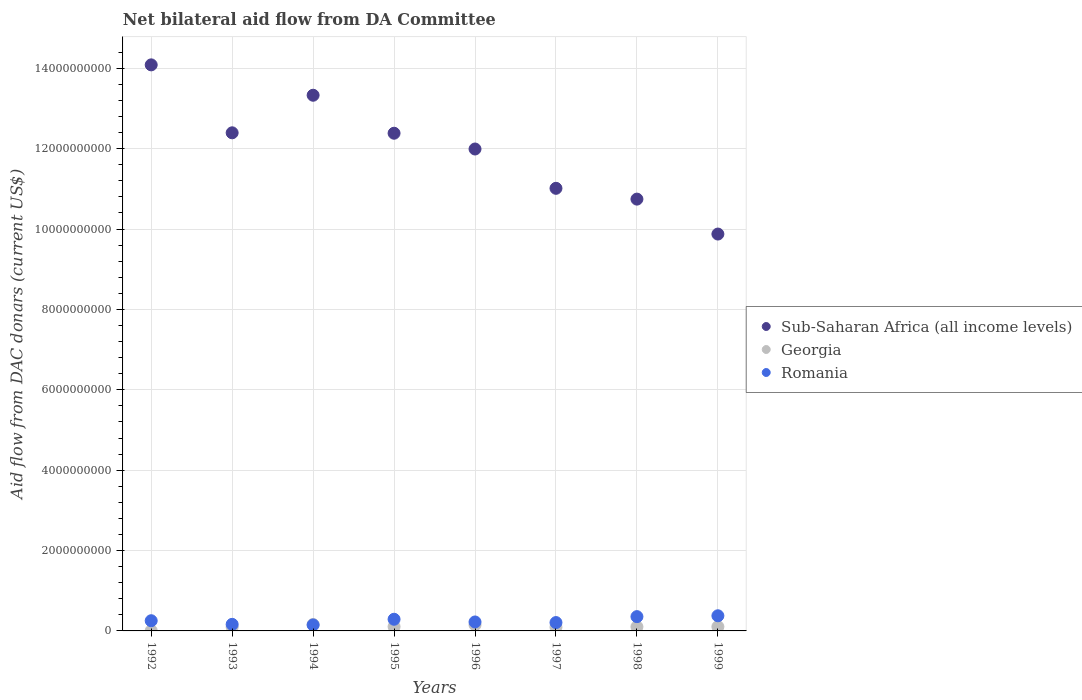How many different coloured dotlines are there?
Keep it short and to the point. 3. Is the number of dotlines equal to the number of legend labels?
Your answer should be very brief. Yes. What is the aid flow in in Sub-Saharan Africa (all income levels) in 1993?
Make the answer very short. 1.24e+1. Across all years, what is the maximum aid flow in in Sub-Saharan Africa (all income levels)?
Ensure brevity in your answer.  1.41e+1. Across all years, what is the minimum aid flow in in Sub-Saharan Africa (all income levels)?
Keep it short and to the point. 9.87e+09. What is the total aid flow in in Romania in the graph?
Offer a terse response. 2.02e+09. What is the difference between the aid flow in in Georgia in 1994 and that in 1996?
Your answer should be very brief. 1.08e+07. What is the difference between the aid flow in in Romania in 1993 and the aid flow in in Georgia in 1998?
Make the answer very short. 6.09e+07. What is the average aid flow in in Sub-Saharan Africa (all income levels) per year?
Keep it short and to the point. 1.20e+1. In the year 1992, what is the difference between the aid flow in in Sub-Saharan Africa (all income levels) and aid flow in in Romania?
Offer a very short reply. 1.38e+1. What is the ratio of the aid flow in in Romania in 1994 to that in 1998?
Your answer should be compact. 0.42. What is the difference between the highest and the second highest aid flow in in Georgia?
Provide a succinct answer. 1.08e+07. What is the difference between the highest and the lowest aid flow in in Romania?
Make the answer very short. 2.29e+08. In how many years, is the aid flow in in Romania greater than the average aid flow in in Romania taken over all years?
Offer a terse response. 4. How many years are there in the graph?
Your answer should be compact. 8. What is the difference between two consecutive major ticks on the Y-axis?
Offer a terse response. 2.00e+09. Does the graph contain any zero values?
Give a very brief answer. No. Does the graph contain grids?
Ensure brevity in your answer.  Yes. How many legend labels are there?
Keep it short and to the point. 3. How are the legend labels stacked?
Ensure brevity in your answer.  Vertical. What is the title of the graph?
Offer a very short reply. Net bilateral aid flow from DA Committee. Does "Bangladesh" appear as one of the legend labels in the graph?
Offer a terse response. No. What is the label or title of the X-axis?
Your answer should be very brief. Years. What is the label or title of the Y-axis?
Provide a succinct answer. Aid flow from DAC donars (current US$). What is the Aid flow from DAC donars (current US$) of Sub-Saharan Africa (all income levels) in 1992?
Offer a terse response. 1.41e+1. What is the Aid flow from DAC donars (current US$) in Georgia in 1992?
Your answer should be compact. 5.28e+06. What is the Aid flow from DAC donars (current US$) in Romania in 1992?
Ensure brevity in your answer.  2.54e+08. What is the Aid flow from DAC donars (current US$) of Sub-Saharan Africa (all income levels) in 1993?
Keep it short and to the point. 1.24e+1. What is the Aid flow from DAC donars (current US$) in Georgia in 1993?
Your answer should be compact. 9.56e+07. What is the Aid flow from DAC donars (current US$) of Romania in 1993?
Ensure brevity in your answer.  1.64e+08. What is the Aid flow from DAC donars (current US$) of Sub-Saharan Africa (all income levels) in 1994?
Your answer should be very brief. 1.33e+1. What is the Aid flow from DAC donars (current US$) in Georgia in 1994?
Offer a very short reply. 1.59e+08. What is the Aid flow from DAC donars (current US$) of Romania in 1994?
Make the answer very short. 1.48e+08. What is the Aid flow from DAC donars (current US$) of Sub-Saharan Africa (all income levels) in 1995?
Your answer should be compact. 1.24e+1. What is the Aid flow from DAC donars (current US$) in Georgia in 1995?
Offer a very short reply. 1.06e+08. What is the Aid flow from DAC donars (current US$) in Romania in 1995?
Your answer should be very brief. 2.90e+08. What is the Aid flow from DAC donars (current US$) in Sub-Saharan Africa (all income levels) in 1996?
Offer a very short reply. 1.20e+1. What is the Aid flow from DAC donars (current US$) in Georgia in 1996?
Your answer should be very brief. 1.48e+08. What is the Aid flow from DAC donars (current US$) in Romania in 1996?
Provide a succinct answer. 2.23e+08. What is the Aid flow from DAC donars (current US$) of Sub-Saharan Africa (all income levels) in 1997?
Offer a very short reply. 1.10e+1. What is the Aid flow from DAC donars (current US$) in Georgia in 1997?
Offer a terse response. 9.18e+07. What is the Aid flow from DAC donars (current US$) of Romania in 1997?
Provide a succinct answer. 2.08e+08. What is the Aid flow from DAC donars (current US$) in Sub-Saharan Africa (all income levels) in 1998?
Your answer should be compact. 1.07e+1. What is the Aid flow from DAC donars (current US$) of Georgia in 1998?
Offer a terse response. 1.03e+08. What is the Aid flow from DAC donars (current US$) in Romania in 1998?
Your answer should be compact. 3.55e+08. What is the Aid flow from DAC donars (current US$) in Sub-Saharan Africa (all income levels) in 1999?
Offer a terse response. 9.87e+09. What is the Aid flow from DAC donars (current US$) in Georgia in 1999?
Make the answer very short. 1.05e+08. What is the Aid flow from DAC donars (current US$) in Romania in 1999?
Provide a short and direct response. 3.77e+08. Across all years, what is the maximum Aid flow from DAC donars (current US$) of Sub-Saharan Africa (all income levels)?
Make the answer very short. 1.41e+1. Across all years, what is the maximum Aid flow from DAC donars (current US$) in Georgia?
Give a very brief answer. 1.59e+08. Across all years, what is the maximum Aid flow from DAC donars (current US$) of Romania?
Offer a very short reply. 3.77e+08. Across all years, what is the minimum Aid flow from DAC donars (current US$) of Sub-Saharan Africa (all income levels)?
Keep it short and to the point. 9.87e+09. Across all years, what is the minimum Aid flow from DAC donars (current US$) of Georgia?
Keep it short and to the point. 5.28e+06. Across all years, what is the minimum Aid flow from DAC donars (current US$) of Romania?
Make the answer very short. 1.48e+08. What is the total Aid flow from DAC donars (current US$) in Sub-Saharan Africa (all income levels) in the graph?
Provide a succinct answer. 9.58e+1. What is the total Aid flow from DAC donars (current US$) in Georgia in the graph?
Ensure brevity in your answer.  8.15e+08. What is the total Aid flow from DAC donars (current US$) in Romania in the graph?
Give a very brief answer. 2.02e+09. What is the difference between the Aid flow from DAC donars (current US$) of Sub-Saharan Africa (all income levels) in 1992 and that in 1993?
Your response must be concise. 1.69e+09. What is the difference between the Aid flow from DAC donars (current US$) in Georgia in 1992 and that in 1993?
Keep it short and to the point. -9.03e+07. What is the difference between the Aid flow from DAC donars (current US$) of Romania in 1992 and that in 1993?
Give a very brief answer. 9.02e+07. What is the difference between the Aid flow from DAC donars (current US$) in Sub-Saharan Africa (all income levels) in 1992 and that in 1994?
Your response must be concise. 7.56e+08. What is the difference between the Aid flow from DAC donars (current US$) in Georgia in 1992 and that in 1994?
Offer a very short reply. -1.54e+08. What is the difference between the Aid flow from DAC donars (current US$) of Romania in 1992 and that in 1994?
Ensure brevity in your answer.  1.05e+08. What is the difference between the Aid flow from DAC donars (current US$) of Sub-Saharan Africa (all income levels) in 1992 and that in 1995?
Your response must be concise. 1.70e+09. What is the difference between the Aid flow from DAC donars (current US$) of Georgia in 1992 and that in 1995?
Your answer should be very brief. -1.01e+08. What is the difference between the Aid flow from DAC donars (current US$) of Romania in 1992 and that in 1995?
Your answer should be compact. -3.64e+07. What is the difference between the Aid flow from DAC donars (current US$) in Sub-Saharan Africa (all income levels) in 1992 and that in 1996?
Your answer should be compact. 2.09e+09. What is the difference between the Aid flow from DAC donars (current US$) in Georgia in 1992 and that in 1996?
Keep it short and to the point. -1.43e+08. What is the difference between the Aid flow from DAC donars (current US$) of Romania in 1992 and that in 1996?
Keep it short and to the point. 3.07e+07. What is the difference between the Aid flow from DAC donars (current US$) in Sub-Saharan Africa (all income levels) in 1992 and that in 1997?
Your answer should be compact. 3.07e+09. What is the difference between the Aid flow from DAC donars (current US$) of Georgia in 1992 and that in 1997?
Ensure brevity in your answer.  -8.65e+07. What is the difference between the Aid flow from DAC donars (current US$) in Romania in 1992 and that in 1997?
Provide a succinct answer. 4.58e+07. What is the difference between the Aid flow from DAC donars (current US$) of Sub-Saharan Africa (all income levels) in 1992 and that in 1998?
Give a very brief answer. 3.34e+09. What is the difference between the Aid flow from DAC donars (current US$) in Georgia in 1992 and that in 1998?
Offer a very short reply. -9.74e+07. What is the difference between the Aid flow from DAC donars (current US$) in Romania in 1992 and that in 1998?
Keep it short and to the point. -1.02e+08. What is the difference between the Aid flow from DAC donars (current US$) of Sub-Saharan Africa (all income levels) in 1992 and that in 1999?
Keep it short and to the point. 4.21e+09. What is the difference between the Aid flow from DAC donars (current US$) in Georgia in 1992 and that in 1999?
Your answer should be very brief. -1.00e+08. What is the difference between the Aid flow from DAC donars (current US$) in Romania in 1992 and that in 1999?
Your answer should be very brief. -1.23e+08. What is the difference between the Aid flow from DAC donars (current US$) of Sub-Saharan Africa (all income levels) in 1993 and that in 1994?
Keep it short and to the point. -9.35e+08. What is the difference between the Aid flow from DAC donars (current US$) of Georgia in 1993 and that in 1994?
Ensure brevity in your answer.  -6.37e+07. What is the difference between the Aid flow from DAC donars (current US$) of Romania in 1993 and that in 1994?
Ensure brevity in your answer.  1.53e+07. What is the difference between the Aid flow from DAC donars (current US$) of Sub-Saharan Africa (all income levels) in 1993 and that in 1995?
Your answer should be compact. 1.05e+07. What is the difference between the Aid flow from DAC donars (current US$) in Georgia in 1993 and that in 1995?
Give a very brief answer. -1.09e+07. What is the difference between the Aid flow from DAC donars (current US$) of Romania in 1993 and that in 1995?
Make the answer very short. -1.27e+08. What is the difference between the Aid flow from DAC donars (current US$) of Sub-Saharan Africa (all income levels) in 1993 and that in 1996?
Your answer should be compact. 4.03e+08. What is the difference between the Aid flow from DAC donars (current US$) in Georgia in 1993 and that in 1996?
Your answer should be very brief. -5.29e+07. What is the difference between the Aid flow from DAC donars (current US$) in Romania in 1993 and that in 1996?
Offer a very short reply. -5.95e+07. What is the difference between the Aid flow from DAC donars (current US$) of Sub-Saharan Africa (all income levels) in 1993 and that in 1997?
Your answer should be very brief. 1.38e+09. What is the difference between the Aid flow from DAC donars (current US$) of Georgia in 1993 and that in 1997?
Give a very brief answer. 3.80e+06. What is the difference between the Aid flow from DAC donars (current US$) of Romania in 1993 and that in 1997?
Provide a succinct answer. -4.44e+07. What is the difference between the Aid flow from DAC donars (current US$) in Sub-Saharan Africa (all income levels) in 1993 and that in 1998?
Give a very brief answer. 1.65e+09. What is the difference between the Aid flow from DAC donars (current US$) in Georgia in 1993 and that in 1998?
Your answer should be compact. -7.10e+06. What is the difference between the Aid flow from DAC donars (current US$) in Romania in 1993 and that in 1998?
Give a very brief answer. -1.92e+08. What is the difference between the Aid flow from DAC donars (current US$) in Sub-Saharan Africa (all income levels) in 1993 and that in 1999?
Keep it short and to the point. 2.52e+09. What is the difference between the Aid flow from DAC donars (current US$) of Georgia in 1993 and that in 1999?
Provide a succinct answer. -9.75e+06. What is the difference between the Aid flow from DAC donars (current US$) of Romania in 1993 and that in 1999?
Ensure brevity in your answer.  -2.13e+08. What is the difference between the Aid flow from DAC donars (current US$) of Sub-Saharan Africa (all income levels) in 1994 and that in 1995?
Ensure brevity in your answer.  9.45e+08. What is the difference between the Aid flow from DAC donars (current US$) of Georgia in 1994 and that in 1995?
Provide a short and direct response. 5.28e+07. What is the difference between the Aid flow from DAC donars (current US$) in Romania in 1994 and that in 1995?
Provide a succinct answer. -1.42e+08. What is the difference between the Aid flow from DAC donars (current US$) of Sub-Saharan Africa (all income levels) in 1994 and that in 1996?
Your response must be concise. 1.34e+09. What is the difference between the Aid flow from DAC donars (current US$) in Georgia in 1994 and that in 1996?
Keep it short and to the point. 1.08e+07. What is the difference between the Aid flow from DAC donars (current US$) of Romania in 1994 and that in 1996?
Make the answer very short. -7.47e+07. What is the difference between the Aid flow from DAC donars (current US$) in Sub-Saharan Africa (all income levels) in 1994 and that in 1997?
Offer a terse response. 2.32e+09. What is the difference between the Aid flow from DAC donars (current US$) of Georgia in 1994 and that in 1997?
Provide a succinct answer. 6.75e+07. What is the difference between the Aid flow from DAC donars (current US$) in Romania in 1994 and that in 1997?
Your response must be concise. -5.97e+07. What is the difference between the Aid flow from DAC donars (current US$) of Sub-Saharan Africa (all income levels) in 1994 and that in 1998?
Your answer should be very brief. 2.58e+09. What is the difference between the Aid flow from DAC donars (current US$) in Georgia in 1994 and that in 1998?
Offer a very short reply. 5.66e+07. What is the difference between the Aid flow from DAC donars (current US$) of Romania in 1994 and that in 1998?
Provide a succinct answer. -2.07e+08. What is the difference between the Aid flow from DAC donars (current US$) of Sub-Saharan Africa (all income levels) in 1994 and that in 1999?
Your answer should be very brief. 3.45e+09. What is the difference between the Aid flow from DAC donars (current US$) of Georgia in 1994 and that in 1999?
Provide a short and direct response. 5.40e+07. What is the difference between the Aid flow from DAC donars (current US$) of Romania in 1994 and that in 1999?
Give a very brief answer. -2.29e+08. What is the difference between the Aid flow from DAC donars (current US$) of Sub-Saharan Africa (all income levels) in 1995 and that in 1996?
Your answer should be compact. 3.93e+08. What is the difference between the Aid flow from DAC donars (current US$) in Georgia in 1995 and that in 1996?
Offer a terse response. -4.20e+07. What is the difference between the Aid flow from DAC donars (current US$) of Romania in 1995 and that in 1996?
Offer a terse response. 6.71e+07. What is the difference between the Aid flow from DAC donars (current US$) of Sub-Saharan Africa (all income levels) in 1995 and that in 1997?
Provide a succinct answer. 1.37e+09. What is the difference between the Aid flow from DAC donars (current US$) of Georgia in 1995 and that in 1997?
Your answer should be compact. 1.47e+07. What is the difference between the Aid flow from DAC donars (current US$) of Romania in 1995 and that in 1997?
Your answer should be very brief. 8.22e+07. What is the difference between the Aid flow from DAC donars (current US$) in Sub-Saharan Africa (all income levels) in 1995 and that in 1998?
Offer a very short reply. 1.64e+09. What is the difference between the Aid flow from DAC donars (current US$) in Georgia in 1995 and that in 1998?
Give a very brief answer. 3.78e+06. What is the difference between the Aid flow from DAC donars (current US$) in Romania in 1995 and that in 1998?
Offer a very short reply. -6.53e+07. What is the difference between the Aid flow from DAC donars (current US$) of Sub-Saharan Africa (all income levels) in 1995 and that in 1999?
Offer a terse response. 2.51e+09. What is the difference between the Aid flow from DAC donars (current US$) in Georgia in 1995 and that in 1999?
Offer a terse response. 1.13e+06. What is the difference between the Aid flow from DAC donars (current US$) of Romania in 1995 and that in 1999?
Keep it short and to the point. -8.68e+07. What is the difference between the Aid flow from DAC donars (current US$) of Sub-Saharan Africa (all income levels) in 1996 and that in 1997?
Keep it short and to the point. 9.78e+08. What is the difference between the Aid flow from DAC donars (current US$) of Georgia in 1996 and that in 1997?
Offer a very short reply. 5.67e+07. What is the difference between the Aid flow from DAC donars (current US$) in Romania in 1996 and that in 1997?
Offer a very short reply. 1.51e+07. What is the difference between the Aid flow from DAC donars (current US$) of Sub-Saharan Africa (all income levels) in 1996 and that in 1998?
Make the answer very short. 1.25e+09. What is the difference between the Aid flow from DAC donars (current US$) of Georgia in 1996 and that in 1998?
Provide a succinct answer. 4.58e+07. What is the difference between the Aid flow from DAC donars (current US$) of Romania in 1996 and that in 1998?
Ensure brevity in your answer.  -1.32e+08. What is the difference between the Aid flow from DAC donars (current US$) in Sub-Saharan Africa (all income levels) in 1996 and that in 1999?
Provide a short and direct response. 2.12e+09. What is the difference between the Aid flow from DAC donars (current US$) of Georgia in 1996 and that in 1999?
Your response must be concise. 4.32e+07. What is the difference between the Aid flow from DAC donars (current US$) of Romania in 1996 and that in 1999?
Your response must be concise. -1.54e+08. What is the difference between the Aid flow from DAC donars (current US$) of Sub-Saharan Africa (all income levels) in 1997 and that in 1998?
Ensure brevity in your answer.  2.69e+08. What is the difference between the Aid flow from DAC donars (current US$) in Georgia in 1997 and that in 1998?
Ensure brevity in your answer.  -1.09e+07. What is the difference between the Aid flow from DAC donars (current US$) in Romania in 1997 and that in 1998?
Provide a succinct answer. -1.47e+08. What is the difference between the Aid flow from DAC donars (current US$) in Sub-Saharan Africa (all income levels) in 1997 and that in 1999?
Provide a succinct answer. 1.14e+09. What is the difference between the Aid flow from DAC donars (current US$) in Georgia in 1997 and that in 1999?
Make the answer very short. -1.36e+07. What is the difference between the Aid flow from DAC donars (current US$) in Romania in 1997 and that in 1999?
Offer a terse response. -1.69e+08. What is the difference between the Aid flow from DAC donars (current US$) of Sub-Saharan Africa (all income levels) in 1998 and that in 1999?
Offer a very short reply. 8.69e+08. What is the difference between the Aid flow from DAC donars (current US$) in Georgia in 1998 and that in 1999?
Your response must be concise. -2.65e+06. What is the difference between the Aid flow from DAC donars (current US$) of Romania in 1998 and that in 1999?
Your response must be concise. -2.15e+07. What is the difference between the Aid flow from DAC donars (current US$) in Sub-Saharan Africa (all income levels) in 1992 and the Aid flow from DAC donars (current US$) in Georgia in 1993?
Make the answer very short. 1.40e+1. What is the difference between the Aid flow from DAC donars (current US$) of Sub-Saharan Africa (all income levels) in 1992 and the Aid flow from DAC donars (current US$) of Romania in 1993?
Provide a succinct answer. 1.39e+1. What is the difference between the Aid flow from DAC donars (current US$) in Georgia in 1992 and the Aid flow from DAC donars (current US$) in Romania in 1993?
Ensure brevity in your answer.  -1.58e+08. What is the difference between the Aid flow from DAC donars (current US$) of Sub-Saharan Africa (all income levels) in 1992 and the Aid flow from DAC donars (current US$) of Georgia in 1994?
Provide a short and direct response. 1.39e+1. What is the difference between the Aid flow from DAC donars (current US$) of Sub-Saharan Africa (all income levels) in 1992 and the Aid flow from DAC donars (current US$) of Romania in 1994?
Your response must be concise. 1.39e+1. What is the difference between the Aid flow from DAC donars (current US$) in Georgia in 1992 and the Aid flow from DAC donars (current US$) in Romania in 1994?
Ensure brevity in your answer.  -1.43e+08. What is the difference between the Aid flow from DAC donars (current US$) in Sub-Saharan Africa (all income levels) in 1992 and the Aid flow from DAC donars (current US$) in Georgia in 1995?
Your answer should be compact. 1.40e+1. What is the difference between the Aid flow from DAC donars (current US$) of Sub-Saharan Africa (all income levels) in 1992 and the Aid flow from DAC donars (current US$) of Romania in 1995?
Your answer should be compact. 1.38e+1. What is the difference between the Aid flow from DAC donars (current US$) of Georgia in 1992 and the Aid flow from DAC donars (current US$) of Romania in 1995?
Keep it short and to the point. -2.85e+08. What is the difference between the Aid flow from DAC donars (current US$) in Sub-Saharan Africa (all income levels) in 1992 and the Aid flow from DAC donars (current US$) in Georgia in 1996?
Provide a short and direct response. 1.39e+1. What is the difference between the Aid flow from DAC donars (current US$) of Sub-Saharan Africa (all income levels) in 1992 and the Aid flow from DAC donars (current US$) of Romania in 1996?
Provide a short and direct response. 1.39e+1. What is the difference between the Aid flow from DAC donars (current US$) in Georgia in 1992 and the Aid flow from DAC donars (current US$) in Romania in 1996?
Provide a short and direct response. -2.18e+08. What is the difference between the Aid flow from DAC donars (current US$) in Sub-Saharan Africa (all income levels) in 1992 and the Aid flow from DAC donars (current US$) in Georgia in 1997?
Your answer should be very brief. 1.40e+1. What is the difference between the Aid flow from DAC donars (current US$) in Sub-Saharan Africa (all income levels) in 1992 and the Aid flow from DAC donars (current US$) in Romania in 1997?
Offer a terse response. 1.39e+1. What is the difference between the Aid flow from DAC donars (current US$) of Georgia in 1992 and the Aid flow from DAC donars (current US$) of Romania in 1997?
Provide a short and direct response. -2.03e+08. What is the difference between the Aid flow from DAC donars (current US$) in Sub-Saharan Africa (all income levels) in 1992 and the Aid flow from DAC donars (current US$) in Georgia in 1998?
Ensure brevity in your answer.  1.40e+1. What is the difference between the Aid flow from DAC donars (current US$) of Sub-Saharan Africa (all income levels) in 1992 and the Aid flow from DAC donars (current US$) of Romania in 1998?
Keep it short and to the point. 1.37e+1. What is the difference between the Aid flow from DAC donars (current US$) in Georgia in 1992 and the Aid flow from DAC donars (current US$) in Romania in 1998?
Your response must be concise. -3.50e+08. What is the difference between the Aid flow from DAC donars (current US$) of Sub-Saharan Africa (all income levels) in 1992 and the Aid flow from DAC donars (current US$) of Georgia in 1999?
Offer a terse response. 1.40e+1. What is the difference between the Aid flow from DAC donars (current US$) in Sub-Saharan Africa (all income levels) in 1992 and the Aid flow from DAC donars (current US$) in Romania in 1999?
Ensure brevity in your answer.  1.37e+1. What is the difference between the Aid flow from DAC donars (current US$) in Georgia in 1992 and the Aid flow from DAC donars (current US$) in Romania in 1999?
Offer a terse response. -3.72e+08. What is the difference between the Aid flow from DAC donars (current US$) in Sub-Saharan Africa (all income levels) in 1993 and the Aid flow from DAC donars (current US$) in Georgia in 1994?
Ensure brevity in your answer.  1.22e+1. What is the difference between the Aid flow from DAC donars (current US$) of Sub-Saharan Africa (all income levels) in 1993 and the Aid flow from DAC donars (current US$) of Romania in 1994?
Your answer should be compact. 1.22e+1. What is the difference between the Aid flow from DAC donars (current US$) in Georgia in 1993 and the Aid flow from DAC donars (current US$) in Romania in 1994?
Offer a terse response. -5.28e+07. What is the difference between the Aid flow from DAC donars (current US$) of Sub-Saharan Africa (all income levels) in 1993 and the Aid flow from DAC donars (current US$) of Georgia in 1995?
Provide a short and direct response. 1.23e+1. What is the difference between the Aid flow from DAC donars (current US$) of Sub-Saharan Africa (all income levels) in 1993 and the Aid flow from DAC donars (current US$) of Romania in 1995?
Provide a succinct answer. 1.21e+1. What is the difference between the Aid flow from DAC donars (current US$) of Georgia in 1993 and the Aid flow from DAC donars (current US$) of Romania in 1995?
Ensure brevity in your answer.  -1.95e+08. What is the difference between the Aid flow from DAC donars (current US$) of Sub-Saharan Africa (all income levels) in 1993 and the Aid flow from DAC donars (current US$) of Georgia in 1996?
Keep it short and to the point. 1.22e+1. What is the difference between the Aid flow from DAC donars (current US$) of Sub-Saharan Africa (all income levels) in 1993 and the Aid flow from DAC donars (current US$) of Romania in 1996?
Offer a terse response. 1.22e+1. What is the difference between the Aid flow from DAC donars (current US$) of Georgia in 1993 and the Aid flow from DAC donars (current US$) of Romania in 1996?
Provide a succinct answer. -1.27e+08. What is the difference between the Aid flow from DAC donars (current US$) in Sub-Saharan Africa (all income levels) in 1993 and the Aid flow from DAC donars (current US$) in Georgia in 1997?
Give a very brief answer. 1.23e+1. What is the difference between the Aid flow from DAC donars (current US$) in Sub-Saharan Africa (all income levels) in 1993 and the Aid flow from DAC donars (current US$) in Romania in 1997?
Your answer should be compact. 1.22e+1. What is the difference between the Aid flow from DAC donars (current US$) of Georgia in 1993 and the Aid flow from DAC donars (current US$) of Romania in 1997?
Provide a short and direct response. -1.12e+08. What is the difference between the Aid flow from DAC donars (current US$) in Sub-Saharan Africa (all income levels) in 1993 and the Aid flow from DAC donars (current US$) in Georgia in 1998?
Your response must be concise. 1.23e+1. What is the difference between the Aid flow from DAC donars (current US$) of Sub-Saharan Africa (all income levels) in 1993 and the Aid flow from DAC donars (current US$) of Romania in 1998?
Offer a very short reply. 1.20e+1. What is the difference between the Aid flow from DAC donars (current US$) of Georgia in 1993 and the Aid flow from DAC donars (current US$) of Romania in 1998?
Offer a terse response. -2.60e+08. What is the difference between the Aid flow from DAC donars (current US$) of Sub-Saharan Africa (all income levels) in 1993 and the Aid flow from DAC donars (current US$) of Georgia in 1999?
Give a very brief answer. 1.23e+1. What is the difference between the Aid flow from DAC donars (current US$) in Sub-Saharan Africa (all income levels) in 1993 and the Aid flow from DAC donars (current US$) in Romania in 1999?
Give a very brief answer. 1.20e+1. What is the difference between the Aid flow from DAC donars (current US$) of Georgia in 1993 and the Aid flow from DAC donars (current US$) of Romania in 1999?
Your answer should be very brief. -2.81e+08. What is the difference between the Aid flow from DAC donars (current US$) in Sub-Saharan Africa (all income levels) in 1994 and the Aid flow from DAC donars (current US$) in Georgia in 1995?
Give a very brief answer. 1.32e+1. What is the difference between the Aid flow from DAC donars (current US$) of Sub-Saharan Africa (all income levels) in 1994 and the Aid flow from DAC donars (current US$) of Romania in 1995?
Ensure brevity in your answer.  1.30e+1. What is the difference between the Aid flow from DAC donars (current US$) in Georgia in 1994 and the Aid flow from DAC donars (current US$) in Romania in 1995?
Provide a succinct answer. -1.31e+08. What is the difference between the Aid flow from DAC donars (current US$) in Sub-Saharan Africa (all income levels) in 1994 and the Aid flow from DAC donars (current US$) in Georgia in 1996?
Give a very brief answer. 1.32e+1. What is the difference between the Aid flow from DAC donars (current US$) of Sub-Saharan Africa (all income levels) in 1994 and the Aid flow from DAC donars (current US$) of Romania in 1996?
Your answer should be very brief. 1.31e+1. What is the difference between the Aid flow from DAC donars (current US$) in Georgia in 1994 and the Aid flow from DAC donars (current US$) in Romania in 1996?
Your answer should be compact. -6.38e+07. What is the difference between the Aid flow from DAC donars (current US$) of Sub-Saharan Africa (all income levels) in 1994 and the Aid flow from DAC donars (current US$) of Georgia in 1997?
Offer a very short reply. 1.32e+1. What is the difference between the Aid flow from DAC donars (current US$) in Sub-Saharan Africa (all income levels) in 1994 and the Aid flow from DAC donars (current US$) in Romania in 1997?
Make the answer very short. 1.31e+1. What is the difference between the Aid flow from DAC donars (current US$) in Georgia in 1994 and the Aid flow from DAC donars (current US$) in Romania in 1997?
Offer a terse response. -4.87e+07. What is the difference between the Aid flow from DAC donars (current US$) in Sub-Saharan Africa (all income levels) in 1994 and the Aid flow from DAC donars (current US$) in Georgia in 1998?
Provide a succinct answer. 1.32e+1. What is the difference between the Aid flow from DAC donars (current US$) in Sub-Saharan Africa (all income levels) in 1994 and the Aid flow from DAC donars (current US$) in Romania in 1998?
Ensure brevity in your answer.  1.30e+1. What is the difference between the Aid flow from DAC donars (current US$) of Georgia in 1994 and the Aid flow from DAC donars (current US$) of Romania in 1998?
Provide a short and direct response. -1.96e+08. What is the difference between the Aid flow from DAC donars (current US$) of Sub-Saharan Africa (all income levels) in 1994 and the Aid flow from DAC donars (current US$) of Georgia in 1999?
Provide a succinct answer. 1.32e+1. What is the difference between the Aid flow from DAC donars (current US$) of Sub-Saharan Africa (all income levels) in 1994 and the Aid flow from DAC donars (current US$) of Romania in 1999?
Your response must be concise. 1.30e+1. What is the difference between the Aid flow from DAC donars (current US$) of Georgia in 1994 and the Aid flow from DAC donars (current US$) of Romania in 1999?
Make the answer very short. -2.18e+08. What is the difference between the Aid flow from DAC donars (current US$) in Sub-Saharan Africa (all income levels) in 1995 and the Aid flow from DAC donars (current US$) in Georgia in 1996?
Provide a succinct answer. 1.22e+1. What is the difference between the Aid flow from DAC donars (current US$) of Sub-Saharan Africa (all income levels) in 1995 and the Aid flow from DAC donars (current US$) of Romania in 1996?
Make the answer very short. 1.22e+1. What is the difference between the Aid flow from DAC donars (current US$) of Georgia in 1995 and the Aid flow from DAC donars (current US$) of Romania in 1996?
Ensure brevity in your answer.  -1.17e+08. What is the difference between the Aid flow from DAC donars (current US$) in Sub-Saharan Africa (all income levels) in 1995 and the Aid flow from DAC donars (current US$) in Georgia in 1997?
Offer a terse response. 1.23e+1. What is the difference between the Aid flow from DAC donars (current US$) of Sub-Saharan Africa (all income levels) in 1995 and the Aid flow from DAC donars (current US$) of Romania in 1997?
Provide a short and direct response. 1.22e+1. What is the difference between the Aid flow from DAC donars (current US$) of Georgia in 1995 and the Aid flow from DAC donars (current US$) of Romania in 1997?
Make the answer very short. -1.02e+08. What is the difference between the Aid flow from DAC donars (current US$) of Sub-Saharan Africa (all income levels) in 1995 and the Aid flow from DAC donars (current US$) of Georgia in 1998?
Your answer should be very brief. 1.23e+1. What is the difference between the Aid flow from DAC donars (current US$) in Sub-Saharan Africa (all income levels) in 1995 and the Aid flow from DAC donars (current US$) in Romania in 1998?
Give a very brief answer. 1.20e+1. What is the difference between the Aid flow from DAC donars (current US$) in Georgia in 1995 and the Aid flow from DAC donars (current US$) in Romania in 1998?
Ensure brevity in your answer.  -2.49e+08. What is the difference between the Aid flow from DAC donars (current US$) in Sub-Saharan Africa (all income levels) in 1995 and the Aid flow from DAC donars (current US$) in Georgia in 1999?
Offer a terse response. 1.23e+1. What is the difference between the Aid flow from DAC donars (current US$) of Sub-Saharan Africa (all income levels) in 1995 and the Aid flow from DAC donars (current US$) of Romania in 1999?
Keep it short and to the point. 1.20e+1. What is the difference between the Aid flow from DAC donars (current US$) of Georgia in 1995 and the Aid flow from DAC donars (current US$) of Romania in 1999?
Offer a terse response. -2.70e+08. What is the difference between the Aid flow from DAC donars (current US$) of Sub-Saharan Africa (all income levels) in 1996 and the Aid flow from DAC donars (current US$) of Georgia in 1997?
Offer a terse response. 1.19e+1. What is the difference between the Aid flow from DAC donars (current US$) in Sub-Saharan Africa (all income levels) in 1996 and the Aid flow from DAC donars (current US$) in Romania in 1997?
Your answer should be very brief. 1.18e+1. What is the difference between the Aid flow from DAC donars (current US$) in Georgia in 1996 and the Aid flow from DAC donars (current US$) in Romania in 1997?
Offer a very short reply. -5.95e+07. What is the difference between the Aid flow from DAC donars (current US$) of Sub-Saharan Africa (all income levels) in 1996 and the Aid flow from DAC donars (current US$) of Georgia in 1998?
Provide a short and direct response. 1.19e+1. What is the difference between the Aid flow from DAC donars (current US$) in Sub-Saharan Africa (all income levels) in 1996 and the Aid flow from DAC donars (current US$) in Romania in 1998?
Keep it short and to the point. 1.16e+1. What is the difference between the Aid flow from DAC donars (current US$) in Georgia in 1996 and the Aid flow from DAC donars (current US$) in Romania in 1998?
Offer a terse response. -2.07e+08. What is the difference between the Aid flow from DAC donars (current US$) in Sub-Saharan Africa (all income levels) in 1996 and the Aid flow from DAC donars (current US$) in Georgia in 1999?
Your answer should be compact. 1.19e+1. What is the difference between the Aid flow from DAC donars (current US$) of Sub-Saharan Africa (all income levels) in 1996 and the Aid flow from DAC donars (current US$) of Romania in 1999?
Offer a terse response. 1.16e+1. What is the difference between the Aid flow from DAC donars (current US$) in Georgia in 1996 and the Aid flow from DAC donars (current US$) in Romania in 1999?
Your answer should be very brief. -2.28e+08. What is the difference between the Aid flow from DAC donars (current US$) in Sub-Saharan Africa (all income levels) in 1997 and the Aid flow from DAC donars (current US$) in Georgia in 1998?
Offer a very short reply. 1.09e+1. What is the difference between the Aid flow from DAC donars (current US$) of Sub-Saharan Africa (all income levels) in 1997 and the Aid flow from DAC donars (current US$) of Romania in 1998?
Keep it short and to the point. 1.07e+1. What is the difference between the Aid flow from DAC donars (current US$) in Georgia in 1997 and the Aid flow from DAC donars (current US$) in Romania in 1998?
Keep it short and to the point. -2.64e+08. What is the difference between the Aid flow from DAC donars (current US$) in Sub-Saharan Africa (all income levels) in 1997 and the Aid flow from DAC donars (current US$) in Georgia in 1999?
Keep it short and to the point. 1.09e+1. What is the difference between the Aid flow from DAC donars (current US$) in Sub-Saharan Africa (all income levels) in 1997 and the Aid flow from DAC donars (current US$) in Romania in 1999?
Offer a very short reply. 1.06e+1. What is the difference between the Aid flow from DAC donars (current US$) of Georgia in 1997 and the Aid flow from DAC donars (current US$) of Romania in 1999?
Provide a short and direct response. -2.85e+08. What is the difference between the Aid flow from DAC donars (current US$) of Sub-Saharan Africa (all income levels) in 1998 and the Aid flow from DAC donars (current US$) of Georgia in 1999?
Your response must be concise. 1.06e+1. What is the difference between the Aid flow from DAC donars (current US$) in Sub-Saharan Africa (all income levels) in 1998 and the Aid flow from DAC donars (current US$) in Romania in 1999?
Offer a very short reply. 1.04e+1. What is the difference between the Aid flow from DAC donars (current US$) in Georgia in 1998 and the Aid flow from DAC donars (current US$) in Romania in 1999?
Keep it short and to the point. -2.74e+08. What is the average Aid flow from DAC donars (current US$) in Sub-Saharan Africa (all income levels) per year?
Provide a succinct answer. 1.20e+1. What is the average Aid flow from DAC donars (current US$) in Georgia per year?
Provide a short and direct response. 1.02e+08. What is the average Aid flow from DAC donars (current US$) of Romania per year?
Offer a very short reply. 2.52e+08. In the year 1992, what is the difference between the Aid flow from DAC donars (current US$) in Sub-Saharan Africa (all income levels) and Aid flow from DAC donars (current US$) in Georgia?
Ensure brevity in your answer.  1.41e+1. In the year 1992, what is the difference between the Aid flow from DAC donars (current US$) in Sub-Saharan Africa (all income levels) and Aid flow from DAC donars (current US$) in Romania?
Your answer should be very brief. 1.38e+1. In the year 1992, what is the difference between the Aid flow from DAC donars (current US$) in Georgia and Aid flow from DAC donars (current US$) in Romania?
Ensure brevity in your answer.  -2.48e+08. In the year 1993, what is the difference between the Aid flow from DAC donars (current US$) of Sub-Saharan Africa (all income levels) and Aid flow from DAC donars (current US$) of Georgia?
Provide a short and direct response. 1.23e+1. In the year 1993, what is the difference between the Aid flow from DAC donars (current US$) in Sub-Saharan Africa (all income levels) and Aid flow from DAC donars (current US$) in Romania?
Provide a short and direct response. 1.22e+1. In the year 1993, what is the difference between the Aid flow from DAC donars (current US$) of Georgia and Aid flow from DAC donars (current US$) of Romania?
Ensure brevity in your answer.  -6.80e+07. In the year 1994, what is the difference between the Aid flow from DAC donars (current US$) of Sub-Saharan Africa (all income levels) and Aid flow from DAC donars (current US$) of Georgia?
Offer a terse response. 1.32e+1. In the year 1994, what is the difference between the Aid flow from DAC donars (current US$) of Sub-Saharan Africa (all income levels) and Aid flow from DAC donars (current US$) of Romania?
Give a very brief answer. 1.32e+1. In the year 1994, what is the difference between the Aid flow from DAC donars (current US$) in Georgia and Aid flow from DAC donars (current US$) in Romania?
Your response must be concise. 1.10e+07. In the year 1995, what is the difference between the Aid flow from DAC donars (current US$) of Sub-Saharan Africa (all income levels) and Aid flow from DAC donars (current US$) of Georgia?
Provide a short and direct response. 1.23e+1. In the year 1995, what is the difference between the Aid flow from DAC donars (current US$) in Sub-Saharan Africa (all income levels) and Aid flow from DAC donars (current US$) in Romania?
Provide a short and direct response. 1.21e+1. In the year 1995, what is the difference between the Aid flow from DAC donars (current US$) of Georgia and Aid flow from DAC donars (current US$) of Romania?
Provide a short and direct response. -1.84e+08. In the year 1996, what is the difference between the Aid flow from DAC donars (current US$) of Sub-Saharan Africa (all income levels) and Aid flow from DAC donars (current US$) of Georgia?
Offer a very short reply. 1.18e+1. In the year 1996, what is the difference between the Aid flow from DAC donars (current US$) of Sub-Saharan Africa (all income levels) and Aid flow from DAC donars (current US$) of Romania?
Your response must be concise. 1.18e+1. In the year 1996, what is the difference between the Aid flow from DAC donars (current US$) in Georgia and Aid flow from DAC donars (current US$) in Romania?
Make the answer very short. -7.46e+07. In the year 1997, what is the difference between the Aid flow from DAC donars (current US$) in Sub-Saharan Africa (all income levels) and Aid flow from DAC donars (current US$) in Georgia?
Give a very brief answer. 1.09e+1. In the year 1997, what is the difference between the Aid flow from DAC donars (current US$) in Sub-Saharan Africa (all income levels) and Aid flow from DAC donars (current US$) in Romania?
Ensure brevity in your answer.  1.08e+1. In the year 1997, what is the difference between the Aid flow from DAC donars (current US$) of Georgia and Aid flow from DAC donars (current US$) of Romania?
Your response must be concise. -1.16e+08. In the year 1998, what is the difference between the Aid flow from DAC donars (current US$) of Sub-Saharan Africa (all income levels) and Aid flow from DAC donars (current US$) of Georgia?
Your answer should be very brief. 1.06e+1. In the year 1998, what is the difference between the Aid flow from DAC donars (current US$) in Sub-Saharan Africa (all income levels) and Aid flow from DAC donars (current US$) in Romania?
Ensure brevity in your answer.  1.04e+1. In the year 1998, what is the difference between the Aid flow from DAC donars (current US$) of Georgia and Aid flow from DAC donars (current US$) of Romania?
Offer a terse response. -2.53e+08. In the year 1999, what is the difference between the Aid flow from DAC donars (current US$) of Sub-Saharan Africa (all income levels) and Aid flow from DAC donars (current US$) of Georgia?
Your answer should be very brief. 9.77e+09. In the year 1999, what is the difference between the Aid flow from DAC donars (current US$) of Sub-Saharan Africa (all income levels) and Aid flow from DAC donars (current US$) of Romania?
Make the answer very short. 9.50e+09. In the year 1999, what is the difference between the Aid flow from DAC donars (current US$) in Georgia and Aid flow from DAC donars (current US$) in Romania?
Offer a very short reply. -2.72e+08. What is the ratio of the Aid flow from DAC donars (current US$) of Sub-Saharan Africa (all income levels) in 1992 to that in 1993?
Your response must be concise. 1.14. What is the ratio of the Aid flow from DAC donars (current US$) in Georgia in 1992 to that in 1993?
Your answer should be compact. 0.06. What is the ratio of the Aid flow from DAC donars (current US$) in Romania in 1992 to that in 1993?
Provide a succinct answer. 1.55. What is the ratio of the Aid flow from DAC donars (current US$) in Sub-Saharan Africa (all income levels) in 1992 to that in 1994?
Your answer should be very brief. 1.06. What is the ratio of the Aid flow from DAC donars (current US$) in Georgia in 1992 to that in 1994?
Offer a very short reply. 0.03. What is the ratio of the Aid flow from DAC donars (current US$) of Romania in 1992 to that in 1994?
Keep it short and to the point. 1.71. What is the ratio of the Aid flow from DAC donars (current US$) of Sub-Saharan Africa (all income levels) in 1992 to that in 1995?
Offer a very short reply. 1.14. What is the ratio of the Aid flow from DAC donars (current US$) in Georgia in 1992 to that in 1995?
Make the answer very short. 0.05. What is the ratio of the Aid flow from DAC donars (current US$) in Romania in 1992 to that in 1995?
Provide a short and direct response. 0.87. What is the ratio of the Aid flow from DAC donars (current US$) in Sub-Saharan Africa (all income levels) in 1992 to that in 1996?
Provide a succinct answer. 1.17. What is the ratio of the Aid flow from DAC donars (current US$) in Georgia in 1992 to that in 1996?
Make the answer very short. 0.04. What is the ratio of the Aid flow from DAC donars (current US$) in Romania in 1992 to that in 1996?
Make the answer very short. 1.14. What is the ratio of the Aid flow from DAC donars (current US$) of Sub-Saharan Africa (all income levels) in 1992 to that in 1997?
Your answer should be compact. 1.28. What is the ratio of the Aid flow from DAC donars (current US$) in Georgia in 1992 to that in 1997?
Your answer should be very brief. 0.06. What is the ratio of the Aid flow from DAC donars (current US$) of Romania in 1992 to that in 1997?
Your answer should be very brief. 1.22. What is the ratio of the Aid flow from DAC donars (current US$) in Sub-Saharan Africa (all income levels) in 1992 to that in 1998?
Keep it short and to the point. 1.31. What is the ratio of the Aid flow from DAC donars (current US$) in Georgia in 1992 to that in 1998?
Offer a terse response. 0.05. What is the ratio of the Aid flow from DAC donars (current US$) of Romania in 1992 to that in 1998?
Give a very brief answer. 0.71. What is the ratio of the Aid flow from DAC donars (current US$) of Sub-Saharan Africa (all income levels) in 1992 to that in 1999?
Your answer should be very brief. 1.43. What is the ratio of the Aid flow from DAC donars (current US$) in Georgia in 1992 to that in 1999?
Make the answer very short. 0.05. What is the ratio of the Aid flow from DAC donars (current US$) of Romania in 1992 to that in 1999?
Your answer should be compact. 0.67. What is the ratio of the Aid flow from DAC donars (current US$) of Sub-Saharan Africa (all income levels) in 1993 to that in 1994?
Make the answer very short. 0.93. What is the ratio of the Aid flow from DAC donars (current US$) in Georgia in 1993 to that in 1994?
Offer a terse response. 0.6. What is the ratio of the Aid flow from DAC donars (current US$) in Romania in 1993 to that in 1994?
Ensure brevity in your answer.  1.1. What is the ratio of the Aid flow from DAC donars (current US$) of Sub-Saharan Africa (all income levels) in 1993 to that in 1995?
Keep it short and to the point. 1. What is the ratio of the Aid flow from DAC donars (current US$) of Georgia in 1993 to that in 1995?
Keep it short and to the point. 0.9. What is the ratio of the Aid flow from DAC donars (current US$) in Romania in 1993 to that in 1995?
Your response must be concise. 0.56. What is the ratio of the Aid flow from DAC donars (current US$) of Sub-Saharan Africa (all income levels) in 1993 to that in 1996?
Your answer should be compact. 1.03. What is the ratio of the Aid flow from DAC donars (current US$) in Georgia in 1993 to that in 1996?
Give a very brief answer. 0.64. What is the ratio of the Aid flow from DAC donars (current US$) in Romania in 1993 to that in 1996?
Your answer should be compact. 0.73. What is the ratio of the Aid flow from DAC donars (current US$) of Sub-Saharan Africa (all income levels) in 1993 to that in 1997?
Offer a very short reply. 1.13. What is the ratio of the Aid flow from DAC donars (current US$) in Georgia in 1993 to that in 1997?
Give a very brief answer. 1.04. What is the ratio of the Aid flow from DAC donars (current US$) in Romania in 1993 to that in 1997?
Offer a very short reply. 0.79. What is the ratio of the Aid flow from DAC donars (current US$) of Sub-Saharan Africa (all income levels) in 1993 to that in 1998?
Your answer should be compact. 1.15. What is the ratio of the Aid flow from DAC donars (current US$) in Georgia in 1993 to that in 1998?
Provide a short and direct response. 0.93. What is the ratio of the Aid flow from DAC donars (current US$) in Romania in 1993 to that in 1998?
Your response must be concise. 0.46. What is the ratio of the Aid flow from DAC donars (current US$) of Sub-Saharan Africa (all income levels) in 1993 to that in 1999?
Ensure brevity in your answer.  1.26. What is the ratio of the Aid flow from DAC donars (current US$) of Georgia in 1993 to that in 1999?
Your answer should be compact. 0.91. What is the ratio of the Aid flow from DAC donars (current US$) of Romania in 1993 to that in 1999?
Give a very brief answer. 0.43. What is the ratio of the Aid flow from DAC donars (current US$) of Sub-Saharan Africa (all income levels) in 1994 to that in 1995?
Keep it short and to the point. 1.08. What is the ratio of the Aid flow from DAC donars (current US$) of Georgia in 1994 to that in 1995?
Your answer should be compact. 1.5. What is the ratio of the Aid flow from DAC donars (current US$) in Romania in 1994 to that in 1995?
Provide a succinct answer. 0.51. What is the ratio of the Aid flow from DAC donars (current US$) in Sub-Saharan Africa (all income levels) in 1994 to that in 1996?
Make the answer very short. 1.11. What is the ratio of the Aid flow from DAC donars (current US$) in Georgia in 1994 to that in 1996?
Make the answer very short. 1.07. What is the ratio of the Aid flow from DAC donars (current US$) of Romania in 1994 to that in 1996?
Offer a very short reply. 0.67. What is the ratio of the Aid flow from DAC donars (current US$) of Sub-Saharan Africa (all income levels) in 1994 to that in 1997?
Your answer should be very brief. 1.21. What is the ratio of the Aid flow from DAC donars (current US$) of Georgia in 1994 to that in 1997?
Ensure brevity in your answer.  1.74. What is the ratio of the Aid flow from DAC donars (current US$) in Romania in 1994 to that in 1997?
Give a very brief answer. 0.71. What is the ratio of the Aid flow from DAC donars (current US$) in Sub-Saharan Africa (all income levels) in 1994 to that in 1998?
Give a very brief answer. 1.24. What is the ratio of the Aid flow from DAC donars (current US$) in Georgia in 1994 to that in 1998?
Provide a short and direct response. 1.55. What is the ratio of the Aid flow from DAC donars (current US$) in Romania in 1994 to that in 1998?
Your answer should be very brief. 0.42. What is the ratio of the Aid flow from DAC donars (current US$) of Sub-Saharan Africa (all income levels) in 1994 to that in 1999?
Give a very brief answer. 1.35. What is the ratio of the Aid flow from DAC donars (current US$) of Georgia in 1994 to that in 1999?
Offer a terse response. 1.51. What is the ratio of the Aid flow from DAC donars (current US$) in Romania in 1994 to that in 1999?
Provide a succinct answer. 0.39. What is the ratio of the Aid flow from DAC donars (current US$) in Sub-Saharan Africa (all income levels) in 1995 to that in 1996?
Offer a terse response. 1.03. What is the ratio of the Aid flow from DAC donars (current US$) of Georgia in 1995 to that in 1996?
Give a very brief answer. 0.72. What is the ratio of the Aid flow from DAC donars (current US$) of Romania in 1995 to that in 1996?
Provide a short and direct response. 1.3. What is the ratio of the Aid flow from DAC donars (current US$) of Sub-Saharan Africa (all income levels) in 1995 to that in 1997?
Provide a succinct answer. 1.12. What is the ratio of the Aid flow from DAC donars (current US$) in Georgia in 1995 to that in 1997?
Your answer should be very brief. 1.16. What is the ratio of the Aid flow from DAC donars (current US$) in Romania in 1995 to that in 1997?
Keep it short and to the point. 1.4. What is the ratio of the Aid flow from DAC donars (current US$) of Sub-Saharan Africa (all income levels) in 1995 to that in 1998?
Provide a succinct answer. 1.15. What is the ratio of the Aid flow from DAC donars (current US$) of Georgia in 1995 to that in 1998?
Provide a succinct answer. 1.04. What is the ratio of the Aid flow from DAC donars (current US$) in Romania in 1995 to that in 1998?
Your response must be concise. 0.82. What is the ratio of the Aid flow from DAC donars (current US$) of Sub-Saharan Africa (all income levels) in 1995 to that in 1999?
Give a very brief answer. 1.25. What is the ratio of the Aid flow from DAC donars (current US$) in Georgia in 1995 to that in 1999?
Keep it short and to the point. 1.01. What is the ratio of the Aid flow from DAC donars (current US$) in Romania in 1995 to that in 1999?
Your answer should be very brief. 0.77. What is the ratio of the Aid flow from DAC donars (current US$) of Sub-Saharan Africa (all income levels) in 1996 to that in 1997?
Provide a succinct answer. 1.09. What is the ratio of the Aid flow from DAC donars (current US$) of Georgia in 1996 to that in 1997?
Your answer should be compact. 1.62. What is the ratio of the Aid flow from DAC donars (current US$) of Romania in 1996 to that in 1997?
Keep it short and to the point. 1.07. What is the ratio of the Aid flow from DAC donars (current US$) in Sub-Saharan Africa (all income levels) in 1996 to that in 1998?
Give a very brief answer. 1.12. What is the ratio of the Aid flow from DAC donars (current US$) in Georgia in 1996 to that in 1998?
Your answer should be compact. 1.45. What is the ratio of the Aid flow from DAC donars (current US$) of Romania in 1996 to that in 1998?
Offer a terse response. 0.63. What is the ratio of the Aid flow from DAC donars (current US$) in Sub-Saharan Africa (all income levels) in 1996 to that in 1999?
Provide a short and direct response. 1.21. What is the ratio of the Aid flow from DAC donars (current US$) of Georgia in 1996 to that in 1999?
Offer a terse response. 1.41. What is the ratio of the Aid flow from DAC donars (current US$) in Romania in 1996 to that in 1999?
Offer a very short reply. 0.59. What is the ratio of the Aid flow from DAC donars (current US$) in Georgia in 1997 to that in 1998?
Your response must be concise. 0.89. What is the ratio of the Aid flow from DAC donars (current US$) of Romania in 1997 to that in 1998?
Provide a succinct answer. 0.59. What is the ratio of the Aid flow from DAC donars (current US$) in Sub-Saharan Africa (all income levels) in 1997 to that in 1999?
Keep it short and to the point. 1.12. What is the ratio of the Aid flow from DAC donars (current US$) in Georgia in 1997 to that in 1999?
Your answer should be compact. 0.87. What is the ratio of the Aid flow from DAC donars (current US$) in Romania in 1997 to that in 1999?
Make the answer very short. 0.55. What is the ratio of the Aid flow from DAC donars (current US$) in Sub-Saharan Africa (all income levels) in 1998 to that in 1999?
Your answer should be very brief. 1.09. What is the ratio of the Aid flow from DAC donars (current US$) in Georgia in 1998 to that in 1999?
Your answer should be very brief. 0.97. What is the ratio of the Aid flow from DAC donars (current US$) of Romania in 1998 to that in 1999?
Your answer should be very brief. 0.94. What is the difference between the highest and the second highest Aid flow from DAC donars (current US$) of Sub-Saharan Africa (all income levels)?
Your answer should be very brief. 7.56e+08. What is the difference between the highest and the second highest Aid flow from DAC donars (current US$) of Georgia?
Your response must be concise. 1.08e+07. What is the difference between the highest and the second highest Aid flow from DAC donars (current US$) in Romania?
Offer a very short reply. 2.15e+07. What is the difference between the highest and the lowest Aid flow from DAC donars (current US$) of Sub-Saharan Africa (all income levels)?
Provide a short and direct response. 4.21e+09. What is the difference between the highest and the lowest Aid flow from DAC donars (current US$) of Georgia?
Provide a succinct answer. 1.54e+08. What is the difference between the highest and the lowest Aid flow from DAC donars (current US$) in Romania?
Your answer should be compact. 2.29e+08. 